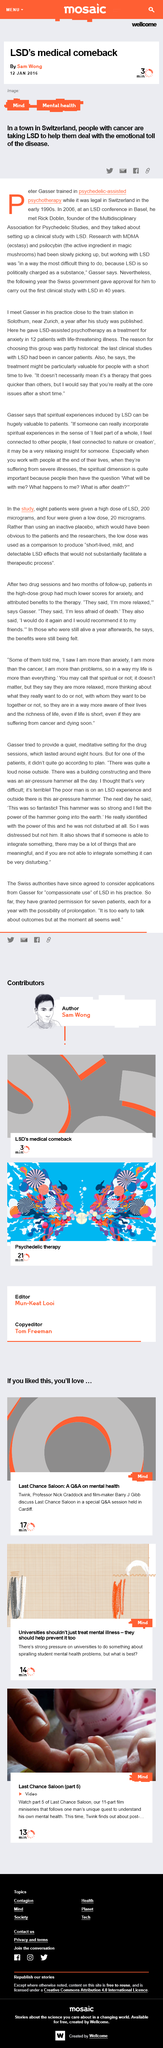Mention a couple of crucial points in this snapshot. Last Chance Saloon is a miniseries consisting of 11 parts. The article titled 'LSD's medical comeback' was published by Sam Wong. In 2006, Peter Gasser and Rick Doblin met at a conference on LSD that took place in Basel, Switzerland. Peter Gasser underwent training in psychedelic assisted psychotherapy. In the article, the name of the miniseries being discussed is "Last Chance Saloon. 